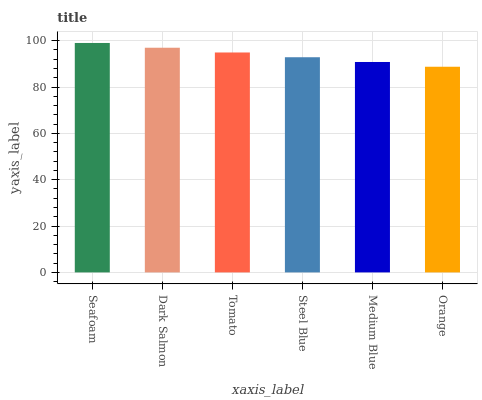Is Orange the minimum?
Answer yes or no. Yes. Is Seafoam the maximum?
Answer yes or no. Yes. Is Dark Salmon the minimum?
Answer yes or no. No. Is Dark Salmon the maximum?
Answer yes or no. No. Is Seafoam greater than Dark Salmon?
Answer yes or no. Yes. Is Dark Salmon less than Seafoam?
Answer yes or no. Yes. Is Dark Salmon greater than Seafoam?
Answer yes or no. No. Is Seafoam less than Dark Salmon?
Answer yes or no. No. Is Tomato the high median?
Answer yes or no. Yes. Is Steel Blue the low median?
Answer yes or no. Yes. Is Seafoam the high median?
Answer yes or no. No. Is Seafoam the low median?
Answer yes or no. No. 